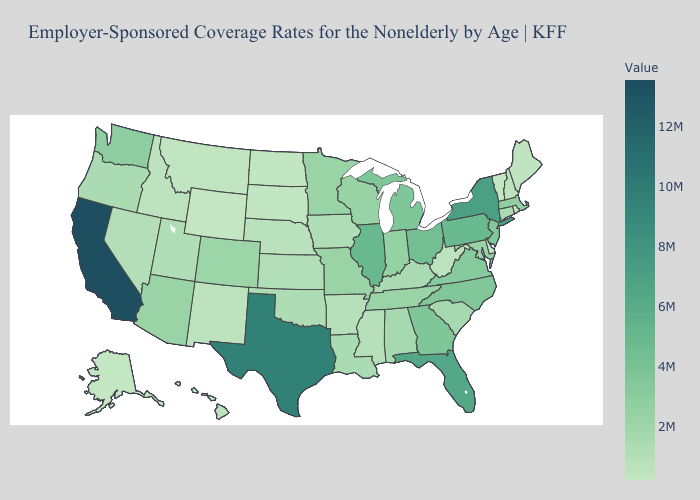Which states have the lowest value in the MidWest?
Keep it brief. North Dakota. Does the map have missing data?
Quick response, please. No. Does the map have missing data?
Concise answer only. No. Among the states that border New Hampshire , does Massachusetts have the highest value?
Quick response, please. Yes. Does the map have missing data?
Short answer required. No. Among the states that border Wyoming , which have the lowest value?
Quick response, please. South Dakota. Does Vermont have the lowest value in the Northeast?
Be succinct. Yes. Among the states that border Iowa , does Illinois have the highest value?
Keep it brief. Yes. 